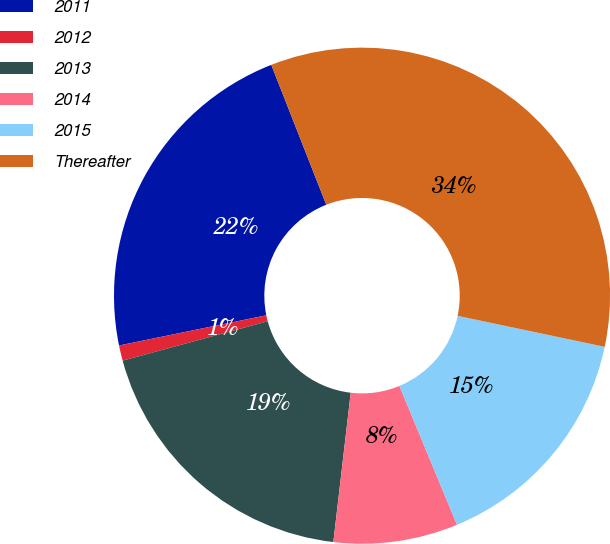<chart> <loc_0><loc_0><loc_500><loc_500><pie_chart><fcel>2011<fcel>2012<fcel>2013<fcel>2014<fcel>2015<fcel>Thereafter<nl><fcel>22.26%<fcel>1.0%<fcel>18.94%<fcel>8.1%<fcel>15.44%<fcel>34.27%<nl></chart> 